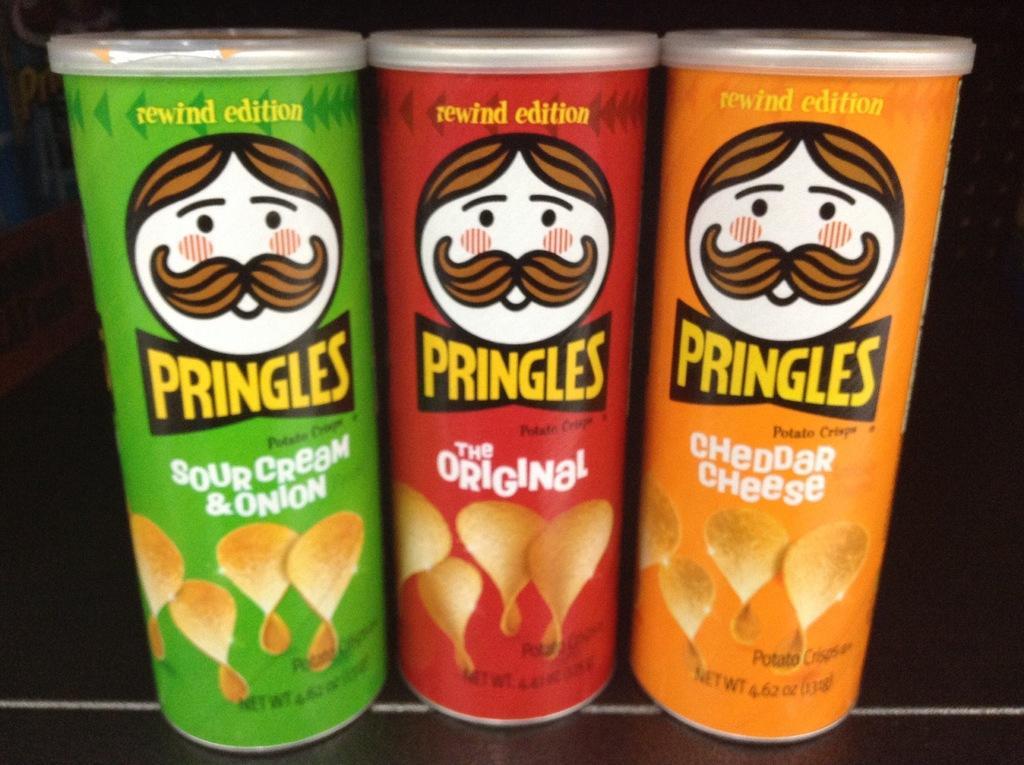How would you summarize this image in a sentence or two? In the image we can see three food containers of different colors. 